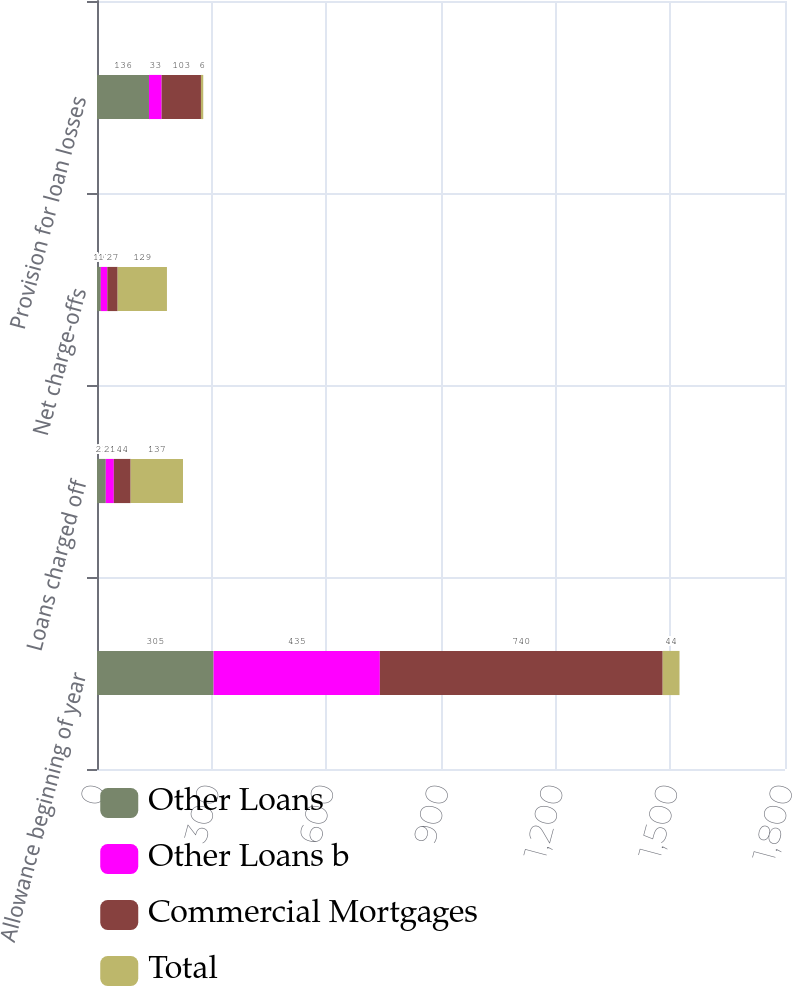Convert chart. <chart><loc_0><loc_0><loc_500><loc_500><stacked_bar_chart><ecel><fcel>Allowance beginning of year<fcel>Loans charged off<fcel>Net charge-offs<fcel>Provision for loan losses<nl><fcel>Other Loans<fcel>305<fcel>23<fcel>10<fcel>136<nl><fcel>Other Loans b<fcel>435<fcel>21<fcel>17<fcel>33<nl><fcel>Commercial Mortgages<fcel>740<fcel>44<fcel>27<fcel>103<nl><fcel>Total<fcel>44<fcel>137<fcel>129<fcel>6<nl></chart> 